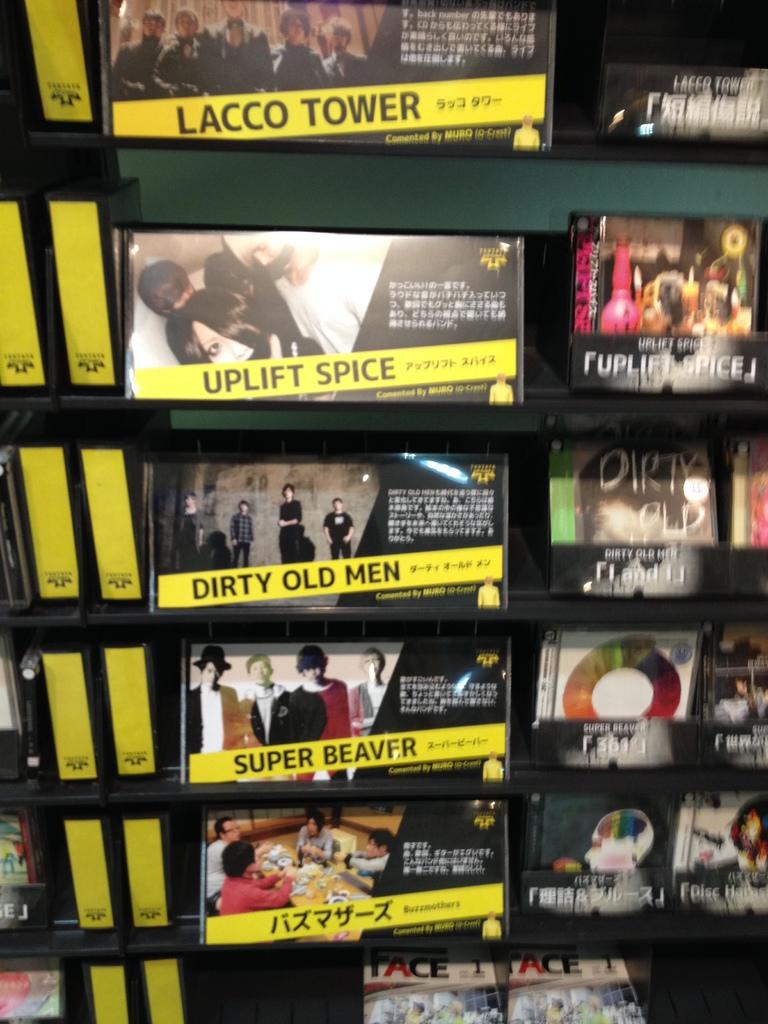What is the name of the top band in the image?
Offer a very short reply. Lacco tower. What is the second-lowest band shown in yellow?
Ensure brevity in your answer.  Super beaver. 